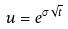<formula> <loc_0><loc_0><loc_500><loc_500>u = e ^ { \sigma \sqrt { t } }</formula> 